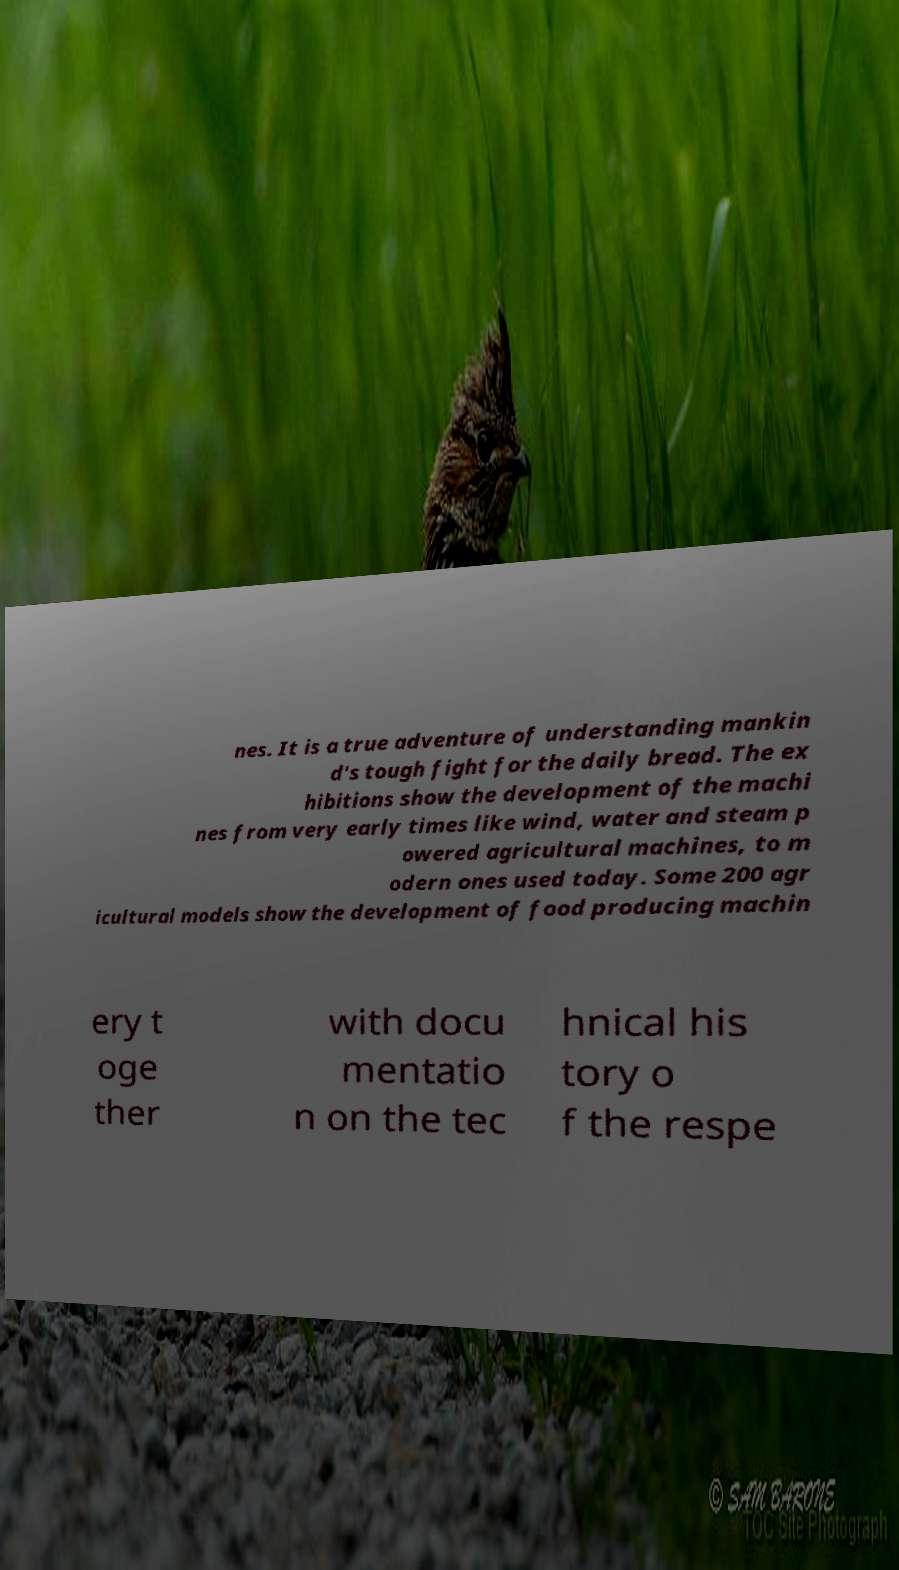I need the written content from this picture converted into text. Can you do that? nes. It is a true adventure of understanding mankin d's tough fight for the daily bread. The ex hibitions show the development of the machi nes from very early times like wind, water and steam p owered agricultural machines, to m odern ones used today. Some 200 agr icultural models show the development of food producing machin ery t oge ther with docu mentatio n on the tec hnical his tory o f the respe 